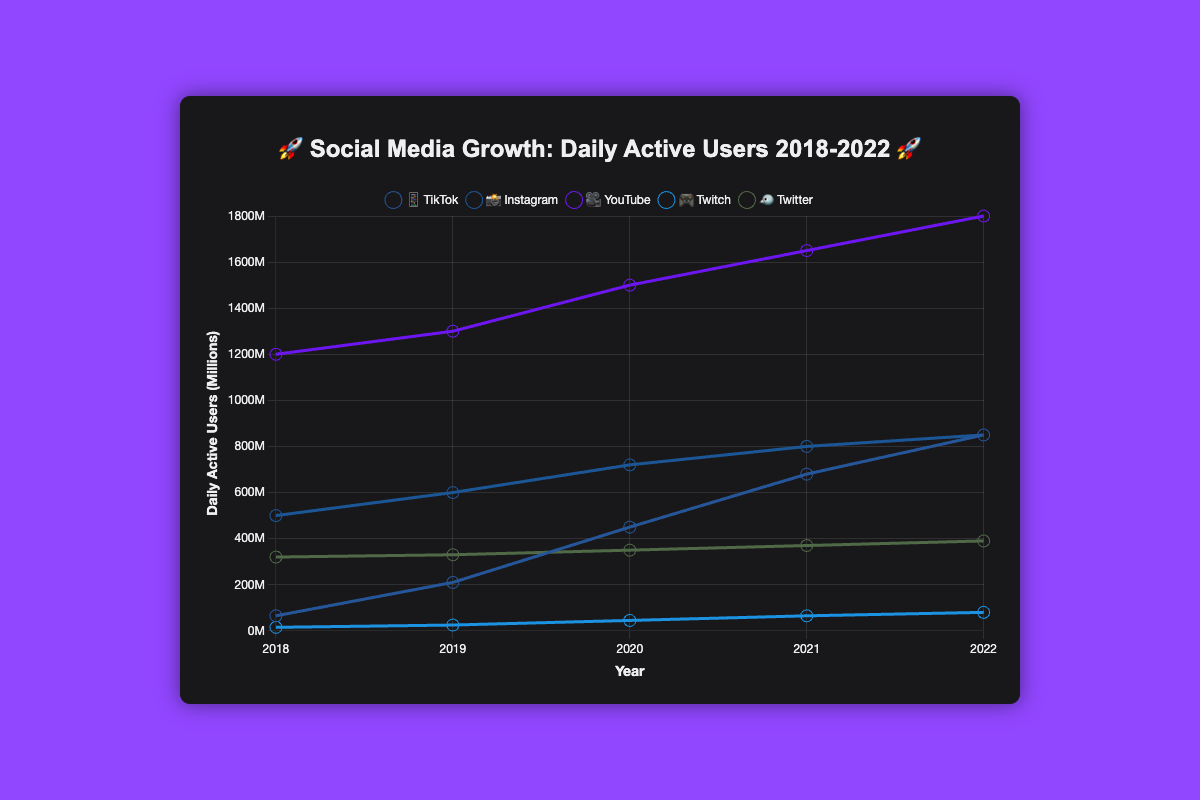How many daily active users did TikTok have in 2018? Look for the year 2018 on the x-axis and then follow up to the datapoint for TikTok, represented by the 📱 emoji. The number corresponding to this is 65 million.
Answer: 65 million Which platform had the highest number of daily active users in 2022? Look for the year 2022 on the x-axis and compare the heights of the datapoints for all platforms. The highest datapoint in 2022 is for YouTube, represented by the 🎥 emoji, which has 1800 million users.
Answer: YouTube How has Twitch’s daily active users changed from 2018 to 2022? Find the series of points for Twitch, represented by the 🎮 emoji, from 2018 to 2022. In 2018 Twitch had 15 million users and in 2022, it had 80 million. Thus, it increased from 15 million to 80 million.
Answer: Increased from 15 million to 80 million Which social media platform had the least growth in daily active users between 2018 and 2022? Calculate the difference in daily active users for each platform from 2018 to 2022. TikTok increased by 785 million, Instagram by 350 million, YouTube by 600 million, Twitch by 65 million, and Twitter by 70 million. Twitch had the smallest increase.
Answer: Twitch By how many millions have Instagram's daily active users increased each year on average from 2018 to 2022? Calculate the total increase for Instagram from 2018 to 2022 which is (850-500) = 350 million. Then, divide this by the number of years, which is 4. The average increase per year is 350 / 4 = 87.5 million.
Answer: 87.5 million What is the difference between the highest and the lowest number of daily active users recorded in 2020 across all platforms? For 2020, TikTok had 450 million, Instagram 720 million, YouTube 1500 million, Twitch 45 million, and Twitter 350 million. The highest is YouTube (1500M) and the lowest is Twitch (45M). The difference is 1500 - 45 = 1455 million.
Answer: 1455 million Which platform had the fastest growth in daily active users from 2018 to 2019? Check the difference in daily active users between 2018 and 2019 for each platform. TikTok increased by 210 - 65 = 145 million, Instagram by 100 million, YouTube by 100 million, Twitch by 10 million, and Twitter by 10 million. The fastest growth was in TikTok, which increased by 145 million.
Answer: TikTok 